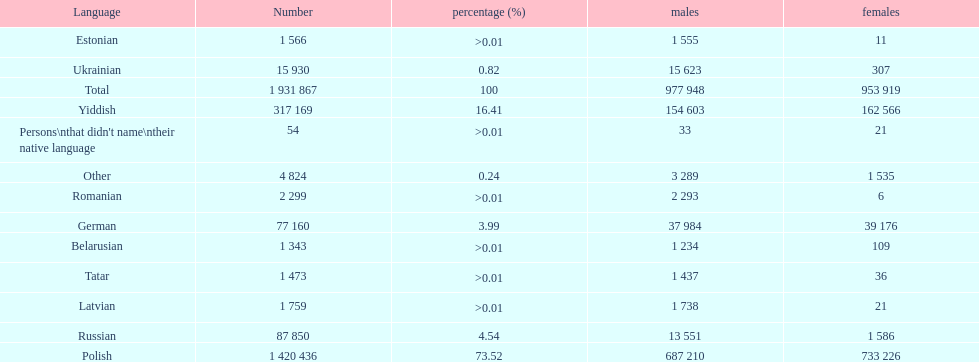Which language had the least female speakers? Romanian. 